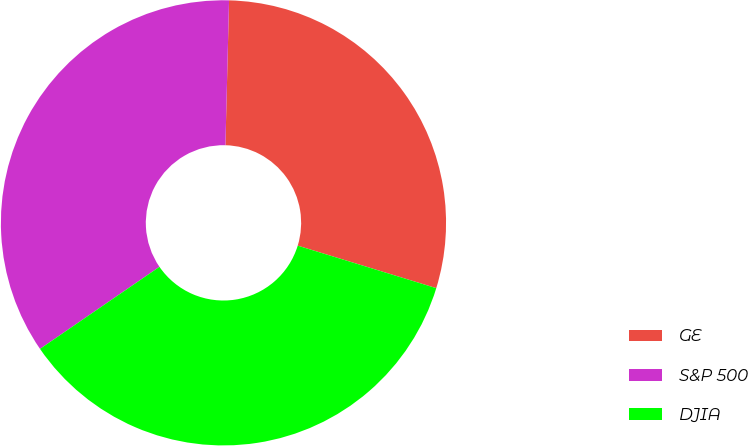Convert chart to OTSL. <chart><loc_0><loc_0><loc_500><loc_500><pie_chart><fcel>GE<fcel>S&P 500<fcel>DJIA<nl><fcel>29.34%<fcel>34.98%<fcel>35.68%<nl></chart> 